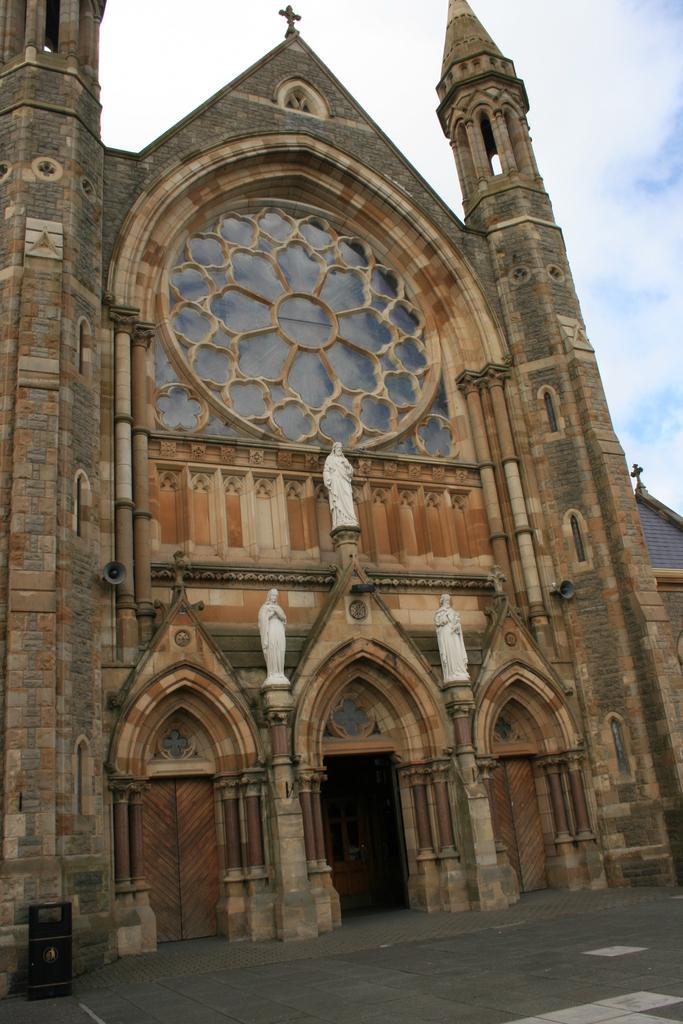Could you give a brief overview of what you see in this image? In the image there is a building with walls, windows, pillars, statues, arches and doors. And also there are doors. At the top of the building there is a cross and also there is roof. At the top of the image there is sky with clouds. 